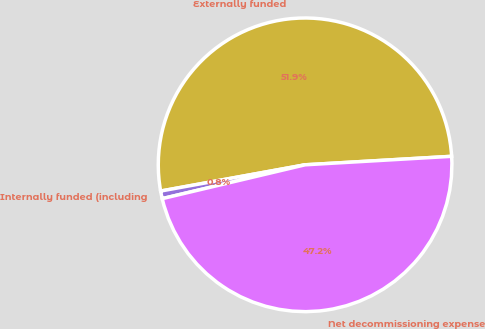<chart> <loc_0><loc_0><loc_500><loc_500><pie_chart><fcel>Externally funded<fcel>Internally funded (including<fcel>Net decommissioning expense<nl><fcel>51.94%<fcel>0.84%<fcel>47.22%<nl></chart> 